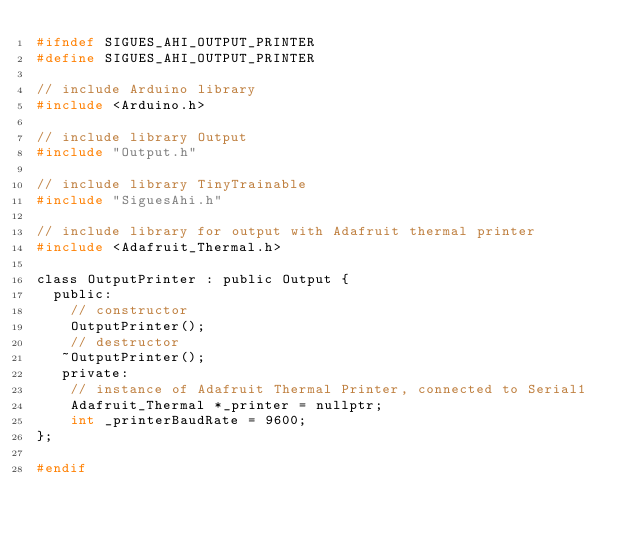Convert code to text. <code><loc_0><loc_0><loc_500><loc_500><_C_>#ifndef SIGUES_AHI_OUTPUT_PRINTER
#define SIGUES_AHI_OUTPUT_PRINTER

// include Arduino library
#include <Arduino.h>

// include library Output
#include "Output.h"

// include library TinyTrainable
#include "SiguesAhi.h"

// include library for output with Adafruit thermal printer
#include <Adafruit_Thermal.h>

class OutputPrinter : public Output {
  public:
    // constructor
    OutputPrinter();
    // destructor
   ~OutputPrinter();
   private:
    // instance of Adafruit Thermal Printer, connected to Serial1
    Adafruit_Thermal *_printer = nullptr;
    int _printerBaudRate = 9600;
};

#endif
</code> 